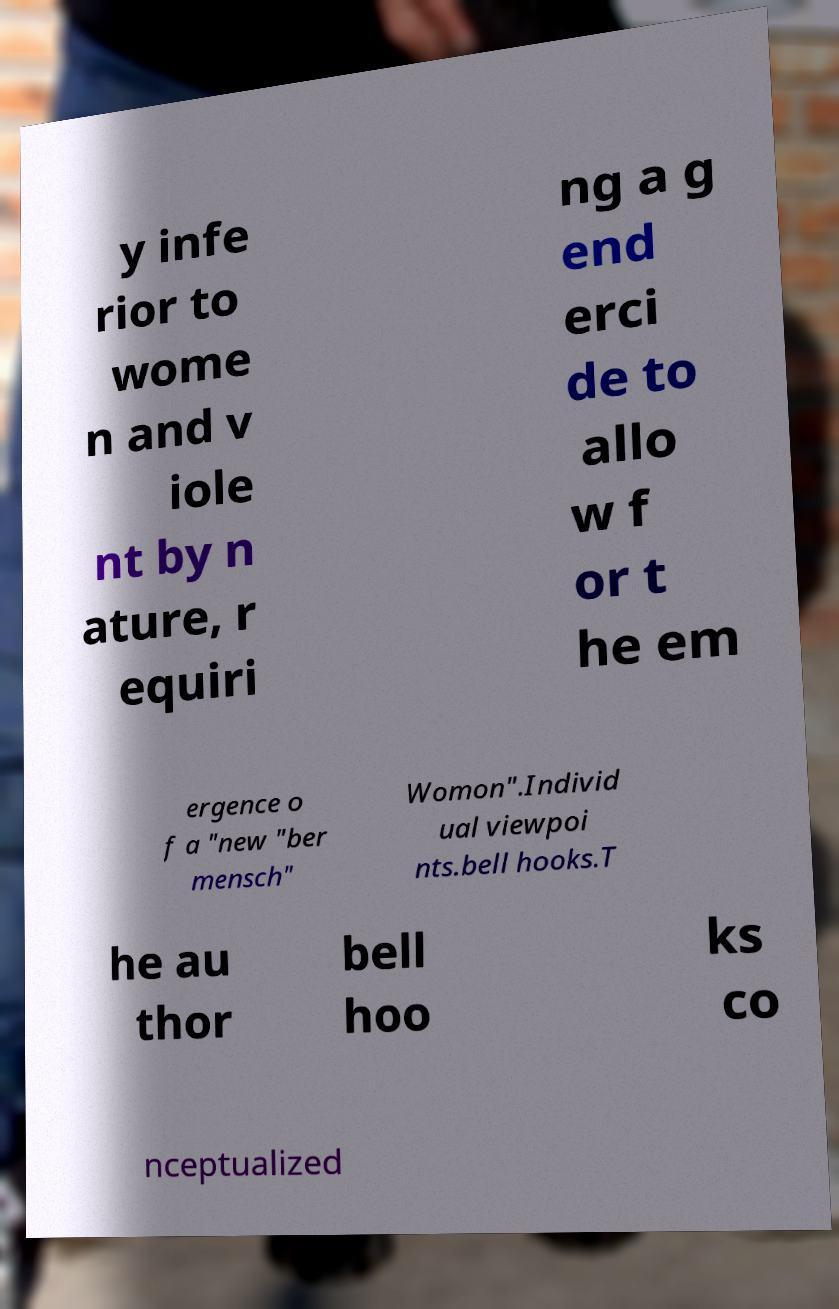Please identify and transcribe the text found in this image. y infe rior to wome n and v iole nt by n ature, r equiri ng a g end erci de to allo w f or t he em ergence o f a "new "ber mensch" Womon".Individ ual viewpoi nts.bell hooks.T he au thor bell hoo ks co nceptualized 